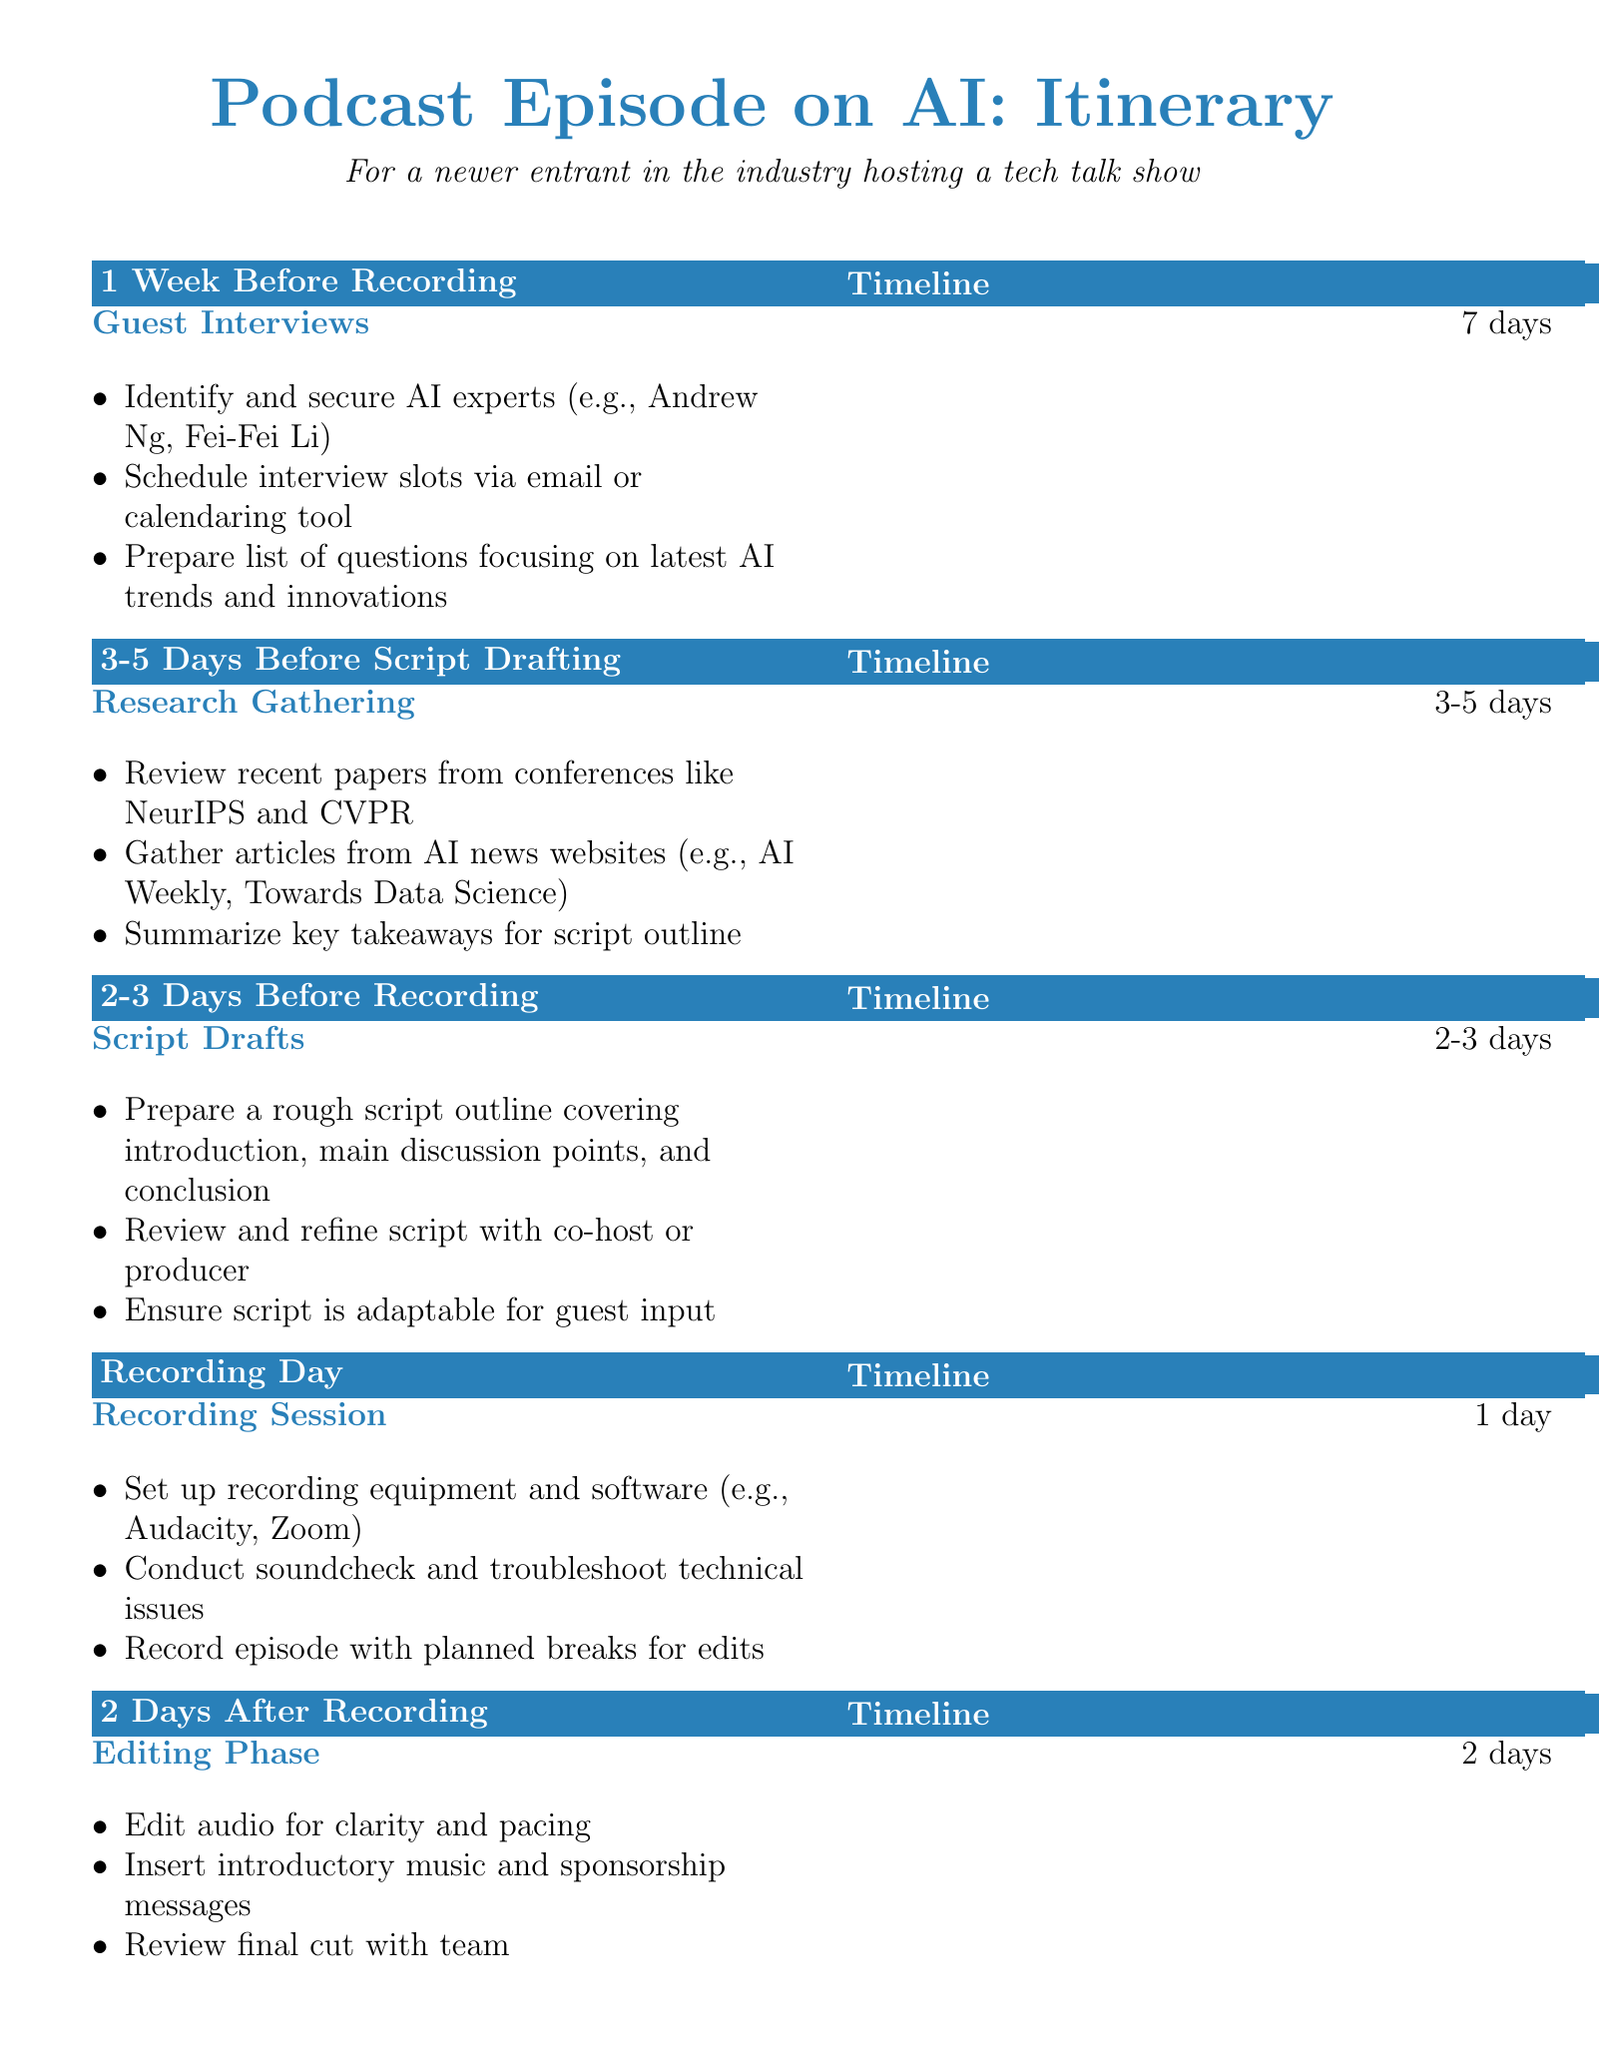What is the title of the document? The title is located at the beginning of the document, which is related to the podcast episode on AI.
Answer: Podcast Episode on AI: Itinerary How many days before recording is the guest interviews section planned? The document states the timeline for guest interviews as 7 days before recording.
Answer: 7 days What activity is listed for 2-3 days before recording? The document specifies the activity planned for that timeframe is script drafts.
Answer: Script Drafts How many days after recording is the editing phase scheduled? The editing phase is specified as occurring 2 days after recording.
Answer: 2 days What type of programs does the document mention for recording sessions? The document lists specific types of software advised for recording sessions.
Answer: Audacity, Zoom What is the focus of the questions prepared for guest interviews? The questions for guest interviews are designed to address a specific area in AI.
Answer: Latest AI trends and innovations What is the primary goal of promotional activities before episode release? The promotional activities aim to create awareness and engagement for the podcast episode.
Answer: Create social media posts and graphics When is the episode release scheduled on podcast platforms? The timeline for releasing the episode is detailed as being done 2 days prior to the release date.
Answer: 2 days before episode release What is the recommendation at the end of the itinerary? The document includes a reminder aimed at maintaining adaptability throughout the planning process.
Answer: Stay flexible and adapt to any last-minute changes or opportunities! 